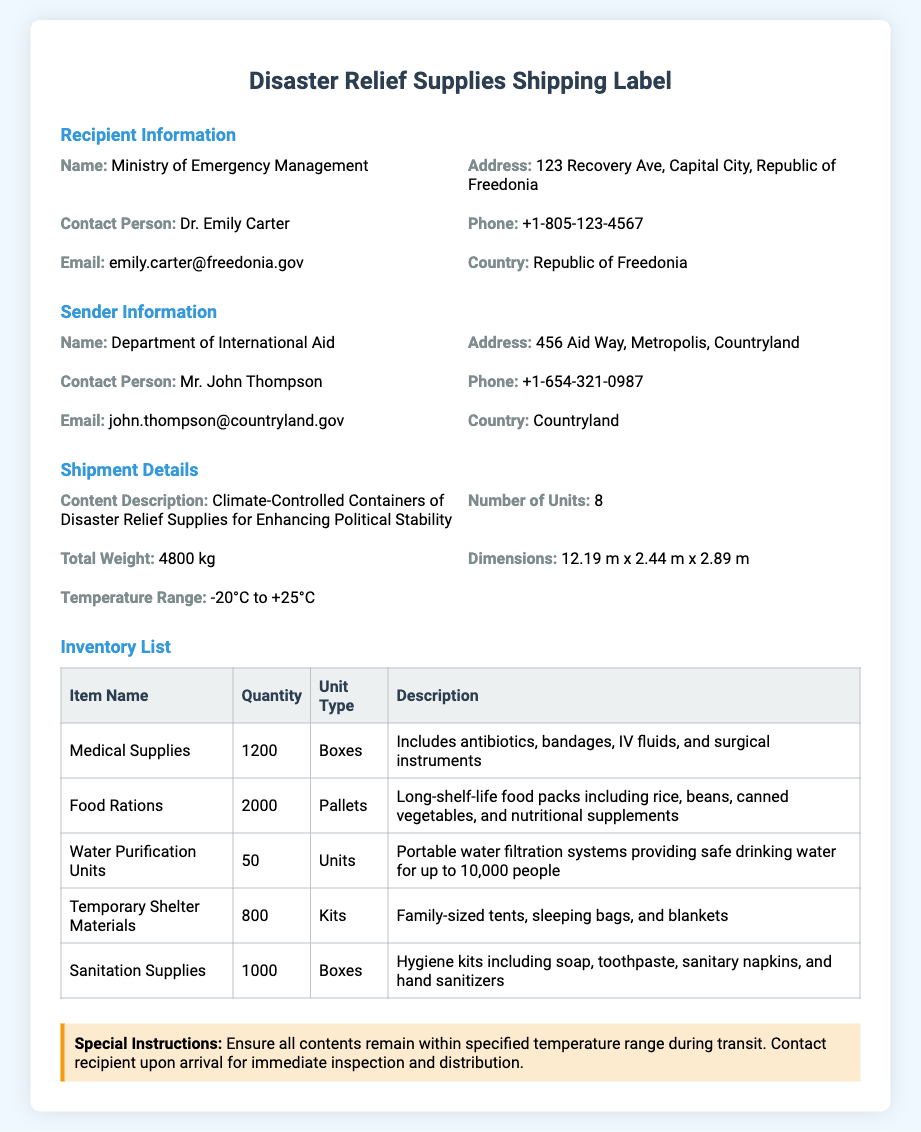what is the name of the recipient organization? The recipient organization is identified as the Ministry of Emergency Management.
Answer: Ministry of Emergency Management what is the total weight of the shipment? The total weight of the shipment is listed in the document as 4800 kg.
Answer: 4800 kg how many units are in the shipment? The document states that there are 8 units being shipped.
Answer: 8 who is the contact person for the sender? The sender's contact person is named as Mr. John Thompson.
Answer: Mr. John Thompson what is the temperature range for the climate-controlled containers? The specified temperature range in the document is from -20°C to +25°C.
Answer: -20°C to +25°C what is included in the hygiene kits? The document describes the hygiene kits as including soap, toothpaste, sanitary napkins, and hand sanitizers.
Answer: soap, toothpaste, sanitary napkins, and hand sanitizers how many pallets of food rations are included? According to the inventory list, there are 2000 pallets of food rations.
Answer: 2000 pallets what should be done upon arrival of the shipment? The special instructions indicate that the recipient should be contacted upon arrival for inspection and distribution.
Answer: contact recipient for inspection and distribution what type of document is this? This document is identified as a shipping label for disaster relief supplies.
Answer: shipping label 